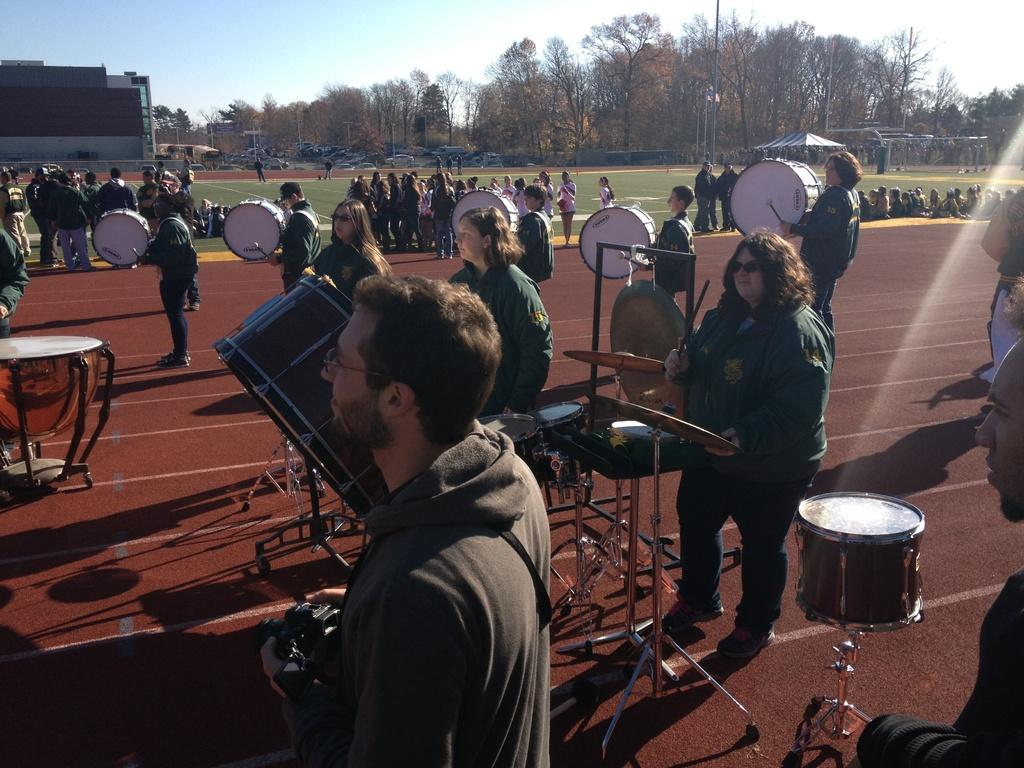What are the people in the image doing? There is a group of people playing drums in the image. Are there any other groups of people in the image? Yes, there are other people in groups behind them. What can be seen in the background of the image? There are trees visible in the background. How many units of ear protection are visible in the image? There is no mention of ear protection or units in the image, so it cannot be determined. 